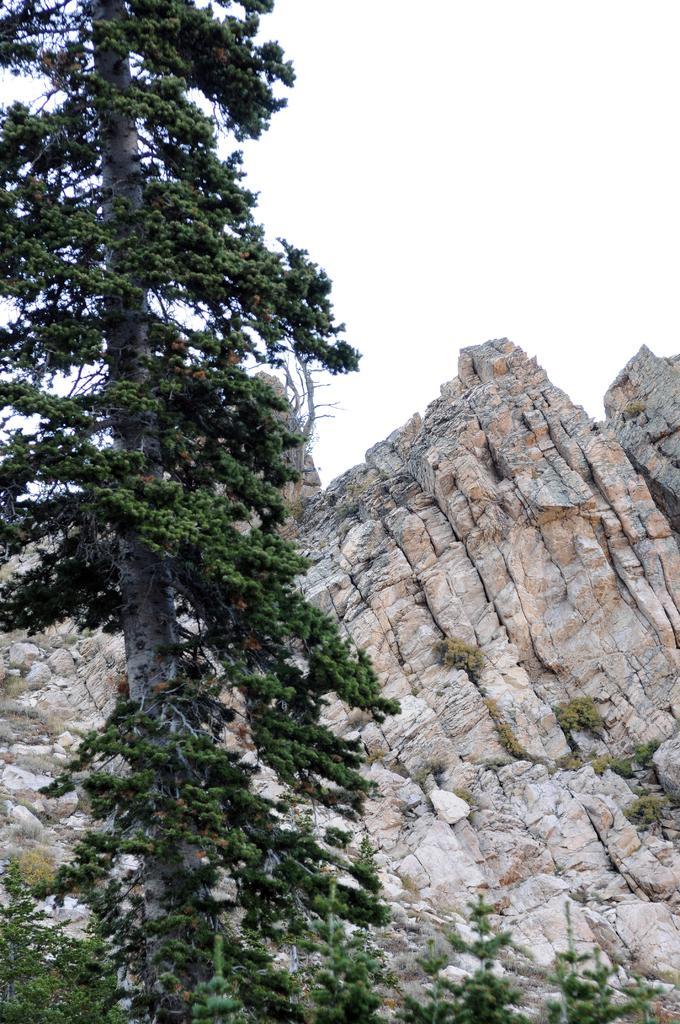In one or two sentences, can you explain what this image depicts? In this image we can see trees and hills. In the background there is sky. 